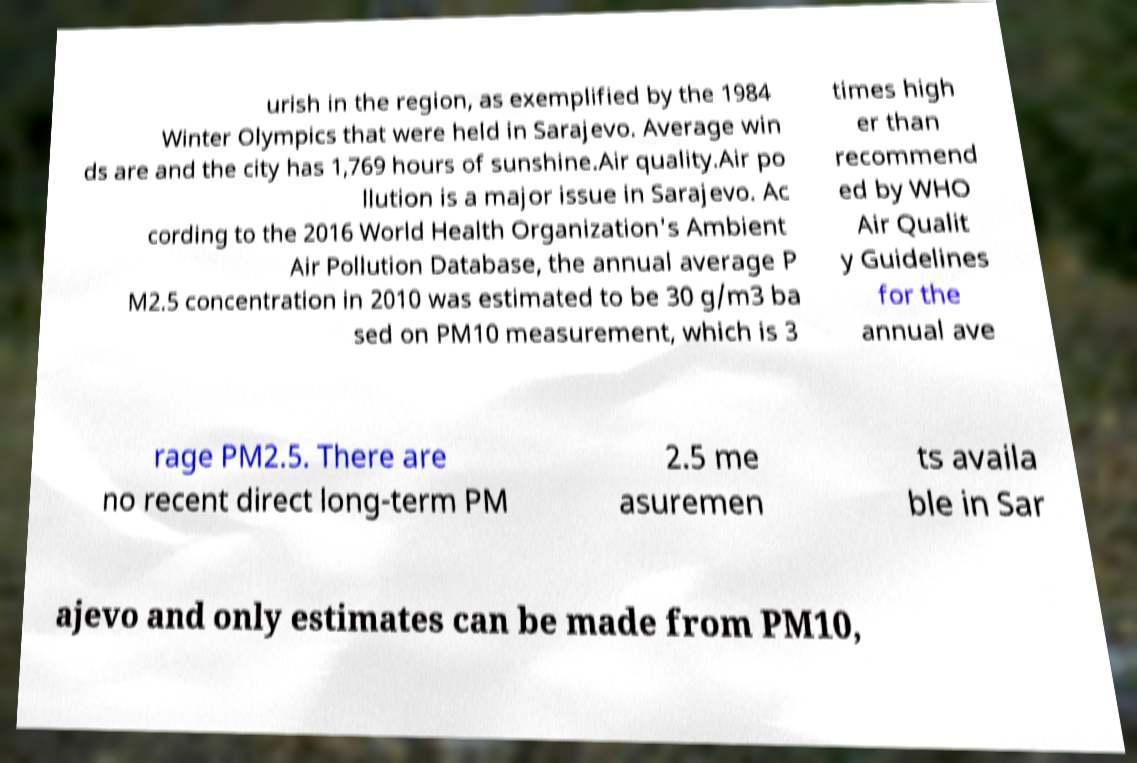For documentation purposes, I need the text within this image transcribed. Could you provide that? urish in the region, as exemplified by the 1984 Winter Olympics that were held in Sarajevo. Average win ds are and the city has 1,769 hours of sunshine.Air quality.Air po llution is a major issue in Sarajevo. Ac cording to the 2016 World Health Organization's Ambient Air Pollution Database, the annual average P M2.5 concentration in 2010 was estimated to be 30 g/m3 ba sed on PM10 measurement, which is 3 times high er than recommend ed by WHO Air Qualit y Guidelines for the annual ave rage PM2.5. There are no recent direct long-term PM 2.5 me asuremen ts availa ble in Sar ajevo and only estimates can be made from PM10, 